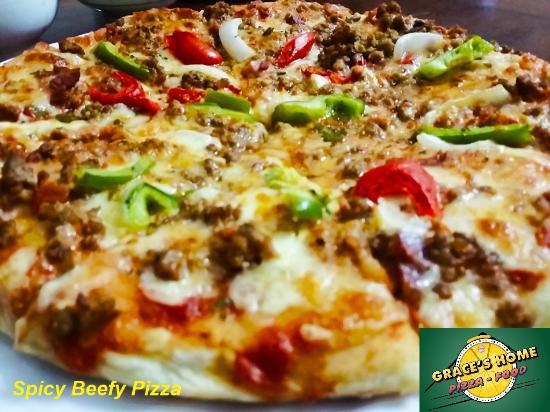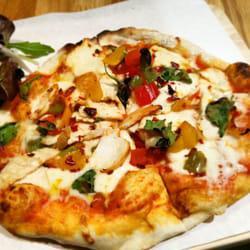The first image is the image on the left, the second image is the image on the right. Given the left and right images, does the statement "The left image shows one round sliced pizza with a single slice out of place, and the right image contains more than one plate of food, including a pizza with green slices on top." hold true? Answer yes or no. No. The first image is the image on the left, the second image is the image on the right. Analyze the images presented: Is the assertion "Exactly one pizza has green peppers on it." valid? Answer yes or no. Yes. 